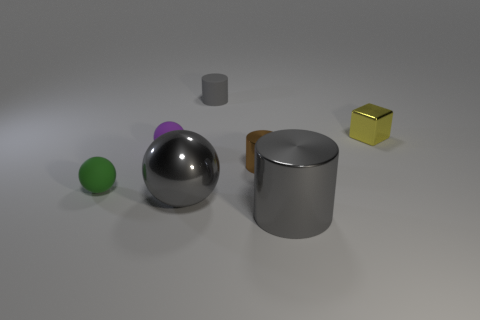Add 2 small purple rubber spheres. How many objects exist? 9 Subtract all spheres. How many objects are left? 4 Add 6 tiny cubes. How many tiny cubes exist? 7 Subtract 0 green blocks. How many objects are left? 7 Subtract all cubes. Subtract all brown metal cylinders. How many objects are left? 5 Add 2 small things. How many small things are left? 7 